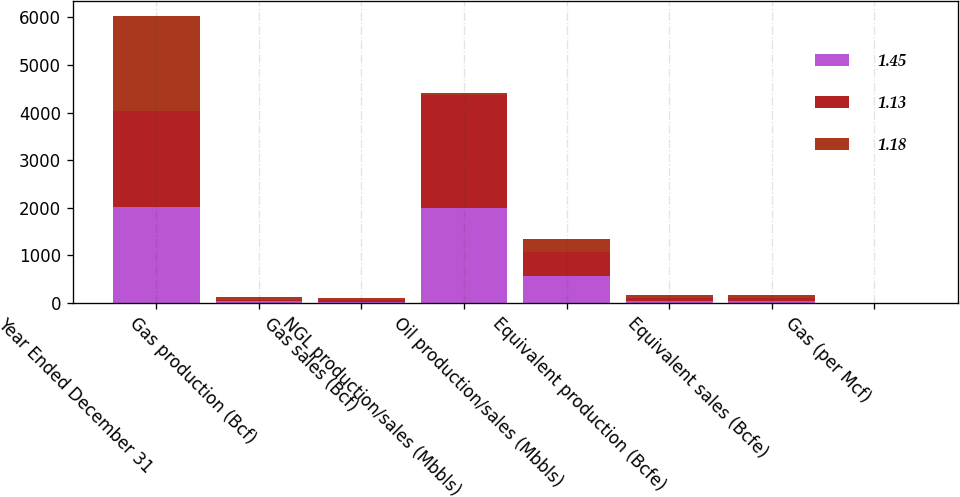<chart> <loc_0><loc_0><loc_500><loc_500><stacked_bar_chart><ecel><fcel>Year Ended December 31<fcel>Gas production (Bcf)<fcel>Gas sales (Bcf)<fcel>NGL production/sales (Mbbls)<fcel>Oil production/sales (Mbbls)<fcel>Equivalent production (Bcfe)<fcel>Equivalent sales (Bcfe)<fcel>Gas (per Mcf)<nl><fcel>1.45<fcel>2013<fcel>33<fcel>30.6<fcel>2002.2<fcel>563.6<fcel>48.4<fcel>46<fcel>3.53<nl><fcel>1.13<fcel>2012<fcel>39.1<fcel>36.6<fcel>2357.2<fcel>501<fcel>56.2<fcel>53.7<fcel>2.67<nl><fcel>1.18<fcel>2011<fcel>45.4<fcel>42.7<fcel>53.7<fcel>282.2<fcel>63.3<fcel>60.6<fcel>3.94<nl></chart> 